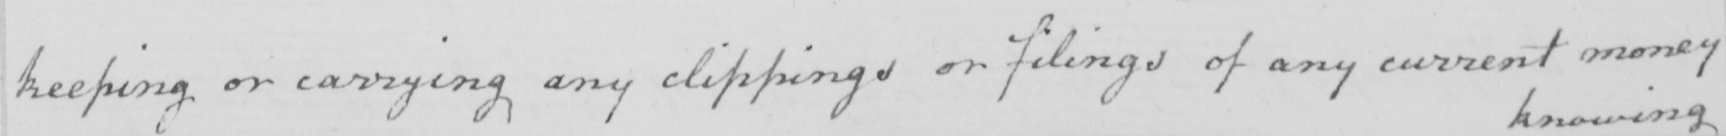Can you read and transcribe this handwriting? keeping or carrying any clippings or filings of any current money 